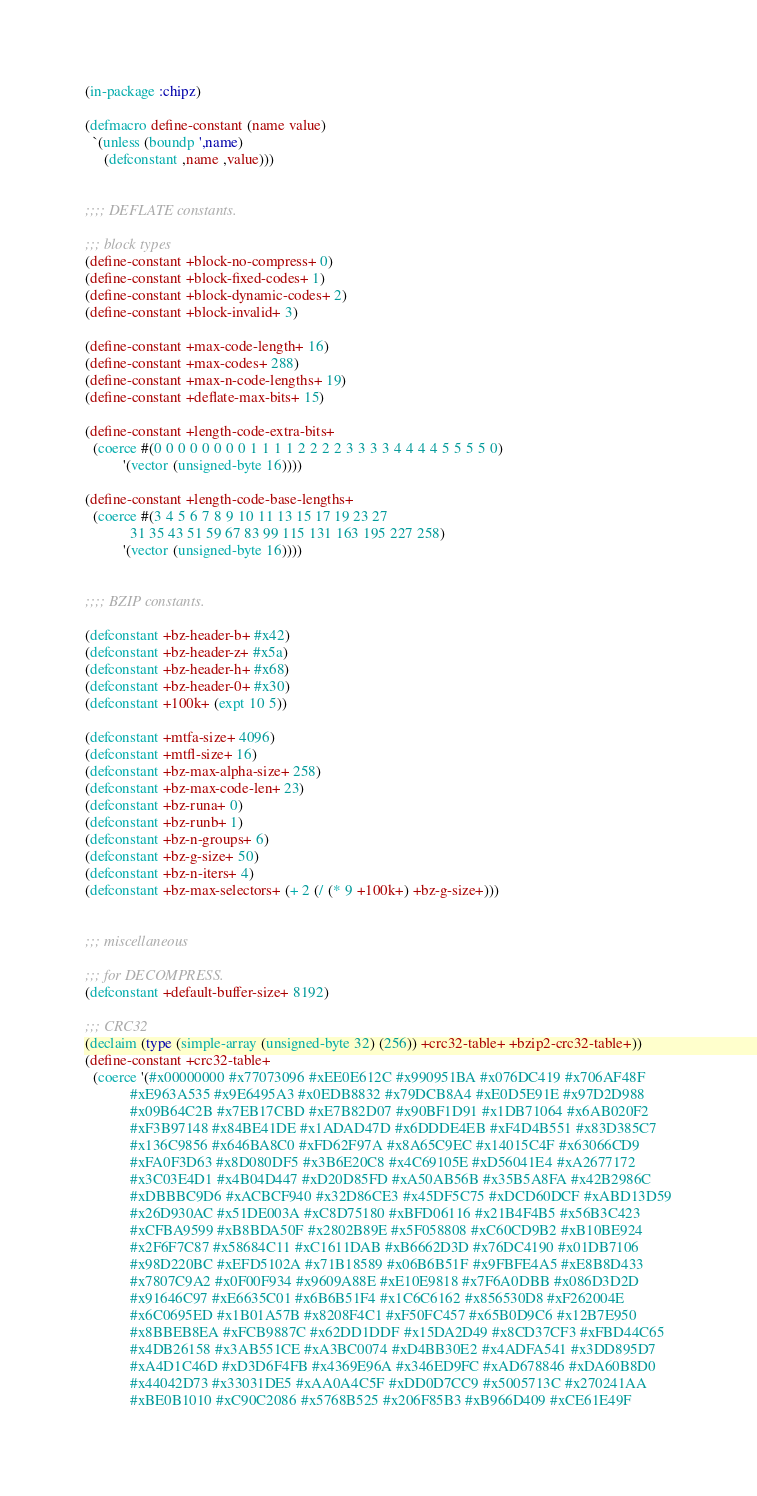Convert code to text. <code><loc_0><loc_0><loc_500><loc_500><_Lisp_>(in-package :chipz)

(defmacro define-constant (name value)
  `(unless (boundp ',name)
     (defconstant ,name ,value)))


;;;; DEFLATE constants.

;;; block types
(define-constant +block-no-compress+ 0)
(define-constant +block-fixed-codes+ 1)
(define-constant +block-dynamic-codes+ 2)
(define-constant +block-invalid+ 3)

(define-constant +max-code-length+ 16)
(define-constant +max-codes+ 288)
(define-constant +max-n-code-lengths+ 19)
(define-constant +deflate-max-bits+ 15)

(define-constant +length-code-extra-bits+
  (coerce #(0 0 0 0 0 0 0 0 1 1 1 1 2 2 2 2 3 3 3 3 4 4 4 4 5 5 5 5 0)
          '(vector (unsigned-byte 16))))

(define-constant +length-code-base-lengths+
  (coerce #(3 4 5 6 7 8 9 10 11 13 15 17 19 23 27
            31 35 43 51 59 67 83 99 115 131 163 195 227 258)
          '(vector (unsigned-byte 16))))


;;;; BZIP constants.

(defconstant +bz-header-b+ #x42)
(defconstant +bz-header-z+ #x5a)
(defconstant +bz-header-h+ #x68)
(defconstant +bz-header-0+ #x30)
(defconstant +100k+ (expt 10 5))

(defconstant +mtfa-size+ 4096)
(defconstant +mtfl-size+ 16)
(defconstant +bz-max-alpha-size+ 258)
(defconstant +bz-max-code-len+ 23)
(defconstant +bz-runa+ 0)
(defconstant +bz-runb+ 1)
(defconstant +bz-n-groups+ 6)
(defconstant +bz-g-size+ 50)
(defconstant +bz-n-iters+ 4)
(defconstant +bz-max-selectors+ (+ 2 (/ (* 9 +100k+) +bz-g-size+)))


;;; miscellaneous

;;; for DECOMPRESS.
(defconstant +default-buffer-size+ 8192)

;;; CRC32
(declaim (type (simple-array (unsigned-byte 32) (256)) +crc32-table+ +bzip2-crc32-table+))
(define-constant +crc32-table+
  (coerce '(#x00000000 #x77073096 #xEE0E612C #x990951BA #x076DC419 #x706AF48F
            #xE963A535 #x9E6495A3 #x0EDB8832 #x79DCB8A4 #xE0D5E91E #x97D2D988
            #x09B64C2B #x7EB17CBD #xE7B82D07 #x90BF1D91 #x1DB71064 #x6AB020F2
            #xF3B97148 #x84BE41DE #x1ADAD47D #x6DDDE4EB #xF4D4B551 #x83D385C7
            #x136C9856 #x646BA8C0 #xFD62F97A #x8A65C9EC #x14015C4F #x63066CD9
            #xFA0F3D63 #x8D080DF5 #x3B6E20C8 #x4C69105E #xD56041E4 #xA2677172
            #x3C03E4D1 #x4B04D447 #xD20D85FD #xA50AB56B #x35B5A8FA #x42B2986C
            #xDBBBC9D6 #xACBCF940 #x32D86CE3 #x45DF5C75 #xDCD60DCF #xABD13D59
            #x26D930AC #x51DE003A #xC8D75180 #xBFD06116 #x21B4F4B5 #x56B3C423
            #xCFBA9599 #xB8BDA50F #x2802B89E #x5F058808 #xC60CD9B2 #xB10BE924
            #x2F6F7C87 #x58684C11 #xC1611DAB #xB6662D3D #x76DC4190 #x01DB7106
            #x98D220BC #xEFD5102A #x71B18589 #x06B6B51F #x9FBFE4A5 #xE8B8D433
            #x7807C9A2 #x0F00F934 #x9609A88E #xE10E9818 #x7F6A0DBB #x086D3D2D
            #x91646C97 #xE6635C01 #x6B6B51F4 #x1C6C6162 #x856530D8 #xF262004E
            #x6C0695ED #x1B01A57B #x8208F4C1 #xF50FC457 #x65B0D9C6 #x12B7E950
            #x8BBEB8EA #xFCB9887C #x62DD1DDF #x15DA2D49 #x8CD37CF3 #xFBD44C65
            #x4DB26158 #x3AB551CE #xA3BC0074 #xD4BB30E2 #x4ADFA541 #x3DD895D7
            #xA4D1C46D #xD3D6F4FB #x4369E96A #x346ED9FC #xAD678846 #xDA60B8D0
            #x44042D73 #x33031DE5 #xAA0A4C5F #xDD0D7CC9 #x5005713C #x270241AA
            #xBE0B1010 #xC90C2086 #x5768B525 #x206F85B3 #xB966D409 #xCE61E49F</code> 